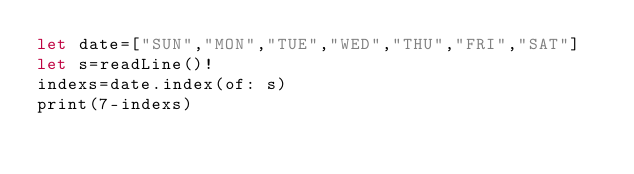Convert code to text. <code><loc_0><loc_0><loc_500><loc_500><_Swift_>let date=["SUN","MON","TUE","WED","THU","FRI","SAT"]
let s=readLine()!
indexs=date.index(of: s)
print(7-indexs)</code> 